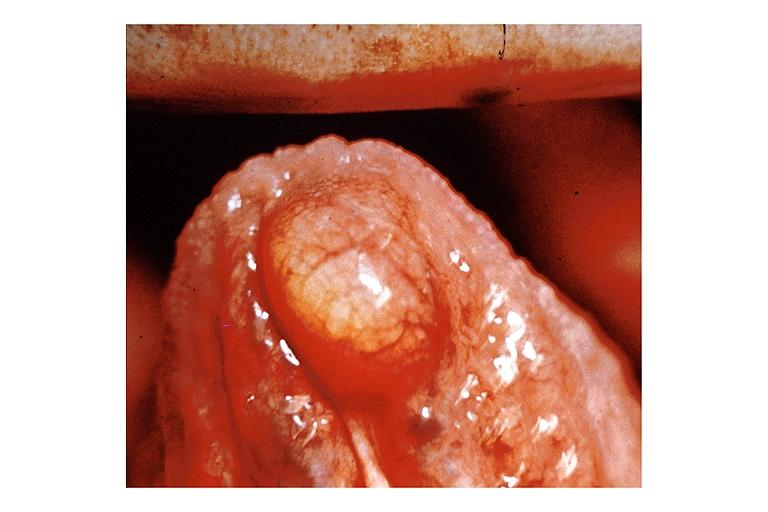s oral present?
Answer the question using a single word or phrase. Yes 